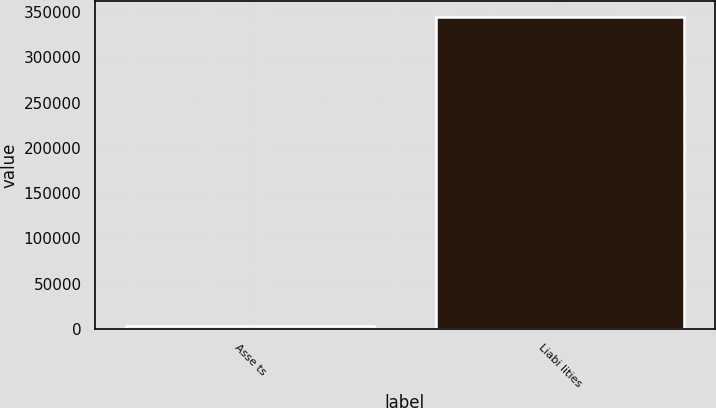Convert chart to OTSL. <chart><loc_0><loc_0><loc_500><loc_500><bar_chart><fcel>Asse ts<fcel>Liabi lities<nl><fcel>3446<fcel>344619<nl></chart> 